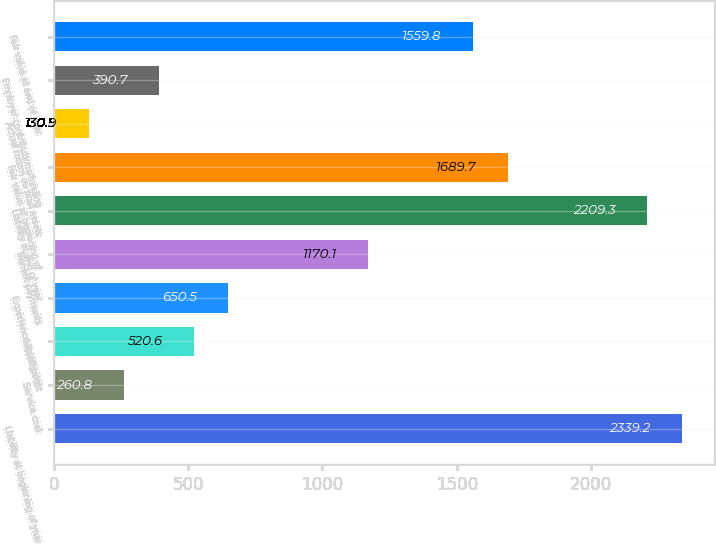<chart> <loc_0><loc_0><loc_500><loc_500><bar_chart><fcel>Liability at beginning of year<fcel>Service cost<fcel>Interest cost<fcel>Experience loss/(gain)<fcel>Benefit payments<fcel>Liability at end of year<fcel>Fair value at beginning of<fcel>Actual return on plan assets<fcel>Employer contributions/funding<fcel>Fair value at end of year<nl><fcel>2339.2<fcel>260.8<fcel>520.6<fcel>650.5<fcel>1170.1<fcel>2209.3<fcel>1689.7<fcel>130.9<fcel>390.7<fcel>1559.8<nl></chart> 